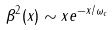<formula> <loc_0><loc_0><loc_500><loc_500>\beta ^ { 2 } ( x ) \sim x e ^ { - x / \omega _ { c } }</formula> 